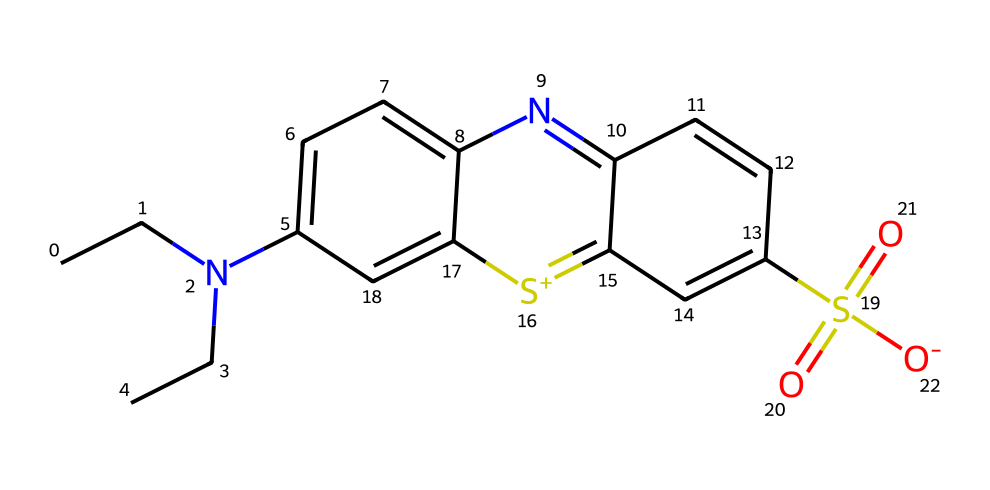What is the main functional group in this molecule? The molecule contains a sulfonyl group (S(=O)(=O)) characterized by the presence of sulfur bonded to two oxygen atoms with double bonds, which signifies its reactivity as a sulfonic acid.
Answer: sulfonyl group How many nitrogen atoms are present in this chemical structure? By analyzing the SMILES representation, we can identify two nitrogen atoms, one in the N-alkyl chain and another in the aromatic heterocycle, contributing to the overall count.
Answer: two What type of dye is indicated by the presence of the sulfur atom here? The sulfur atom is part of a sulfonamide group, typically found in synthetic dyes, indicating that this coloring agent is a type of azo dye with improved water solubility.
Answer: azo dye What are the total numbers of carbon atoms in this chemical? By counting the carbon atoms depicted in the SMILES representation, we observe a total of 15 carbon atoms forming the backbone of the molecule.
Answer: fifteen What type of structure does the presence of aromatic rings suggest about this compound? The presence of two interconnected aromatic rings suggests that this compound possesses a complex organic structure typical of food coloring agents, contributing to color and stability in flavored waters.
Answer: complex organic structure 